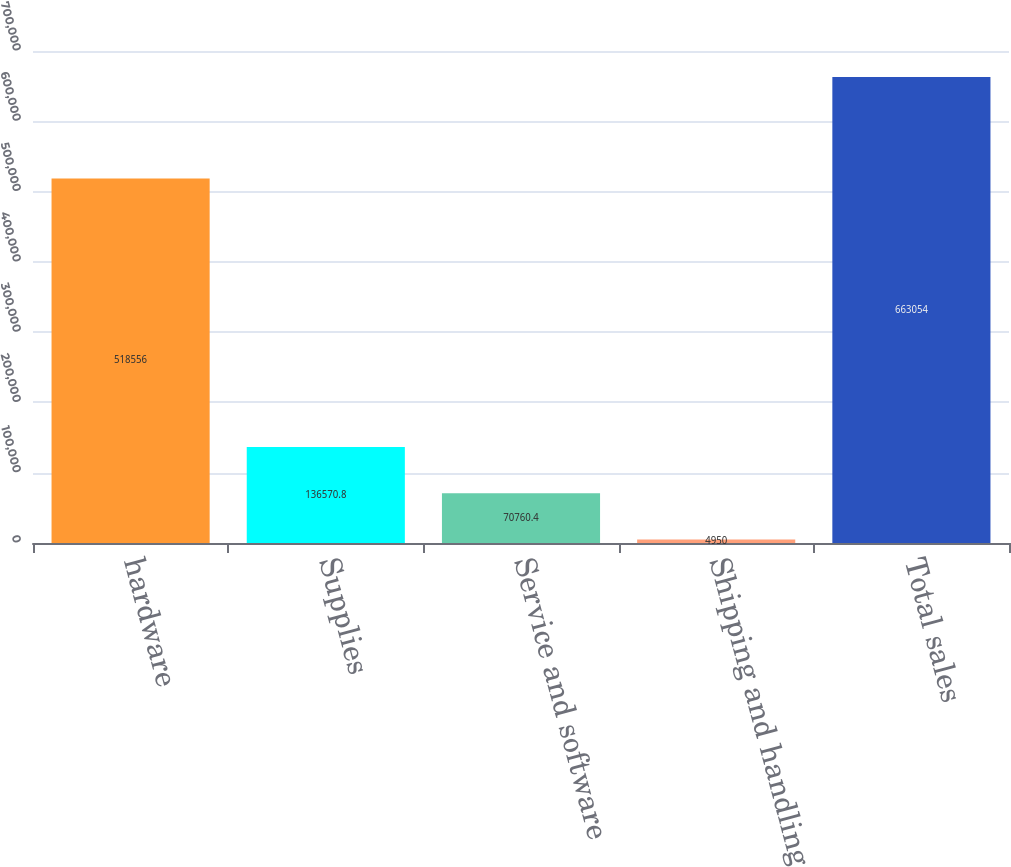<chart> <loc_0><loc_0><loc_500><loc_500><bar_chart><fcel>hardware<fcel>Supplies<fcel>Service and software<fcel>Shipping and handling<fcel>Total sales<nl><fcel>518556<fcel>136571<fcel>70760.4<fcel>4950<fcel>663054<nl></chart> 